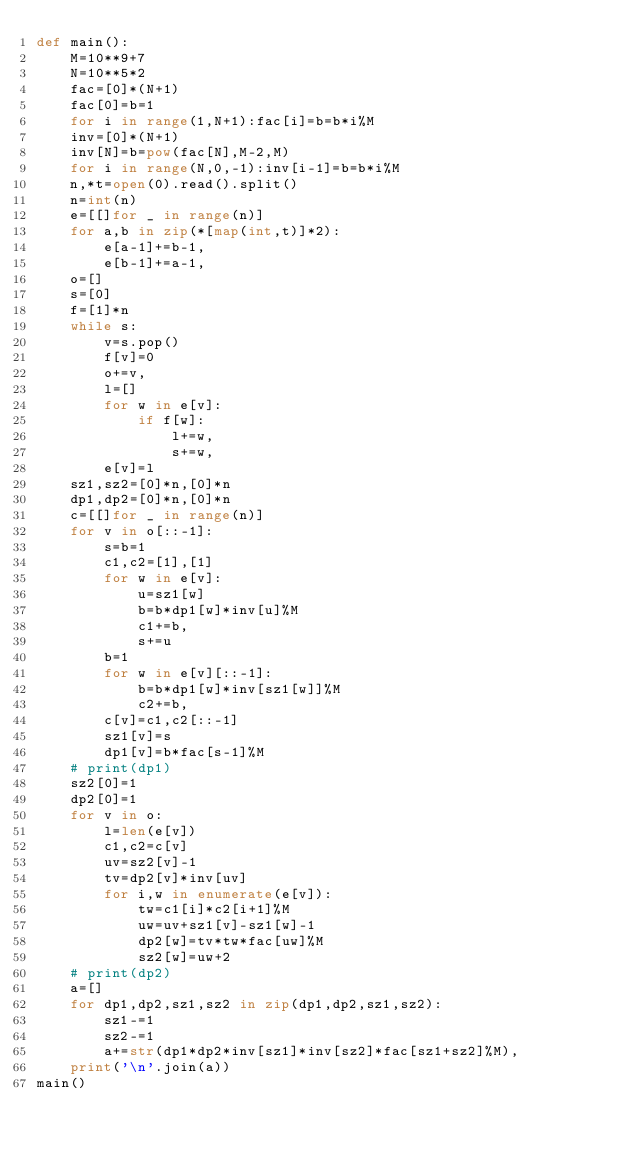Convert code to text. <code><loc_0><loc_0><loc_500><loc_500><_Python_>def main():
    M=10**9+7
    N=10**5*2
    fac=[0]*(N+1)
    fac[0]=b=1
    for i in range(1,N+1):fac[i]=b=b*i%M
    inv=[0]*(N+1)
    inv[N]=b=pow(fac[N],M-2,M)
    for i in range(N,0,-1):inv[i-1]=b=b*i%M
    n,*t=open(0).read().split()
    n=int(n)
    e=[[]for _ in range(n)]
    for a,b in zip(*[map(int,t)]*2):
        e[a-1]+=b-1,
        e[b-1]+=a-1,
    o=[]
    s=[0]
    f=[1]*n
    while s:
        v=s.pop()
        f[v]=0
        o+=v,
        l=[]
        for w in e[v]:
            if f[w]:
                l+=w,
                s+=w,
        e[v]=l
    sz1,sz2=[0]*n,[0]*n
    dp1,dp2=[0]*n,[0]*n
    c=[[]for _ in range(n)]
    for v in o[::-1]:
        s=b=1
        c1,c2=[1],[1]
        for w in e[v]:
            u=sz1[w]
            b=b*dp1[w]*inv[u]%M
            c1+=b,
            s+=u
        b=1
        for w in e[v][::-1]:
            b=b*dp1[w]*inv[sz1[w]]%M
            c2+=b,
        c[v]=c1,c2[::-1]
        sz1[v]=s
        dp1[v]=b*fac[s-1]%M
    # print(dp1)
    sz2[0]=1
    dp2[0]=1
    for v in o:
        l=len(e[v])
        c1,c2=c[v]
        uv=sz2[v]-1
        tv=dp2[v]*inv[uv]
        for i,w in enumerate(e[v]):
            tw=c1[i]*c2[i+1]%M
            uw=uv+sz1[v]-sz1[w]-1
            dp2[w]=tv*tw*fac[uw]%M
            sz2[w]=uw+2
    # print(dp2)
    a=[]
    for dp1,dp2,sz1,sz2 in zip(dp1,dp2,sz1,sz2):
        sz1-=1
        sz2-=1
        a+=str(dp1*dp2*inv[sz1]*inv[sz2]*fac[sz1+sz2]%M),
    print('\n'.join(a))
main()</code> 